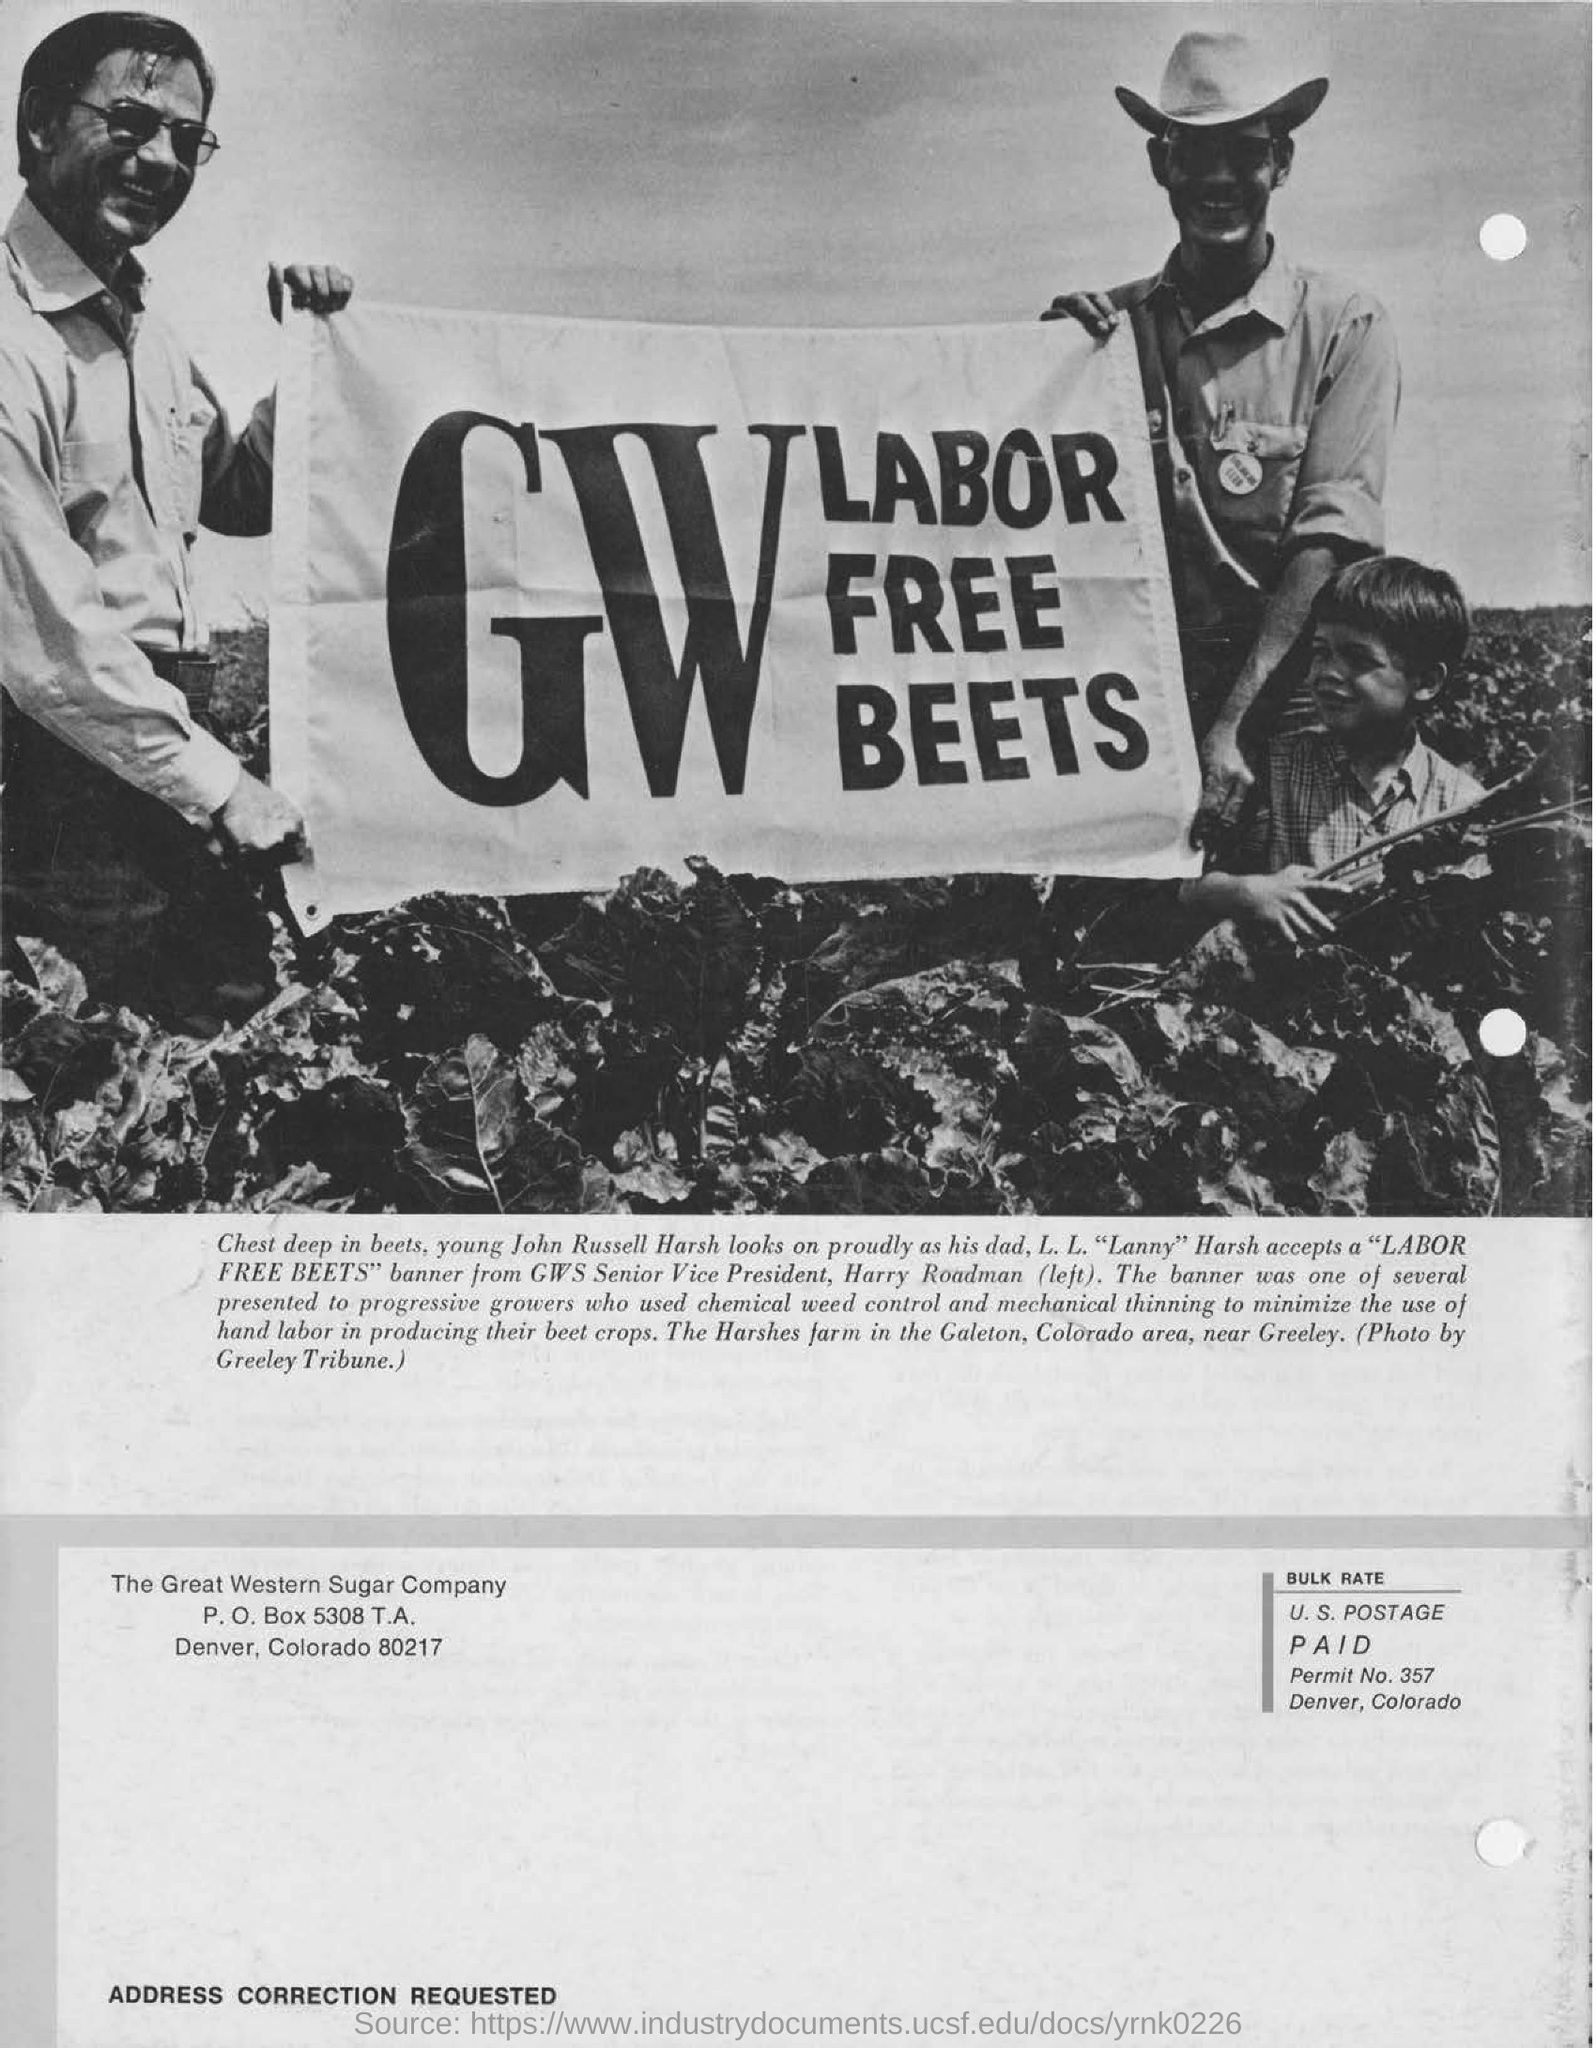What sign are the two people holding up in the picture?
Your answer should be compact. GW LABOR FREE BEETS. Who is harry roadman?
Provide a short and direct response. Gws senior vice president. Who is the photo by?
Your response must be concise. Greeley Tribune. 